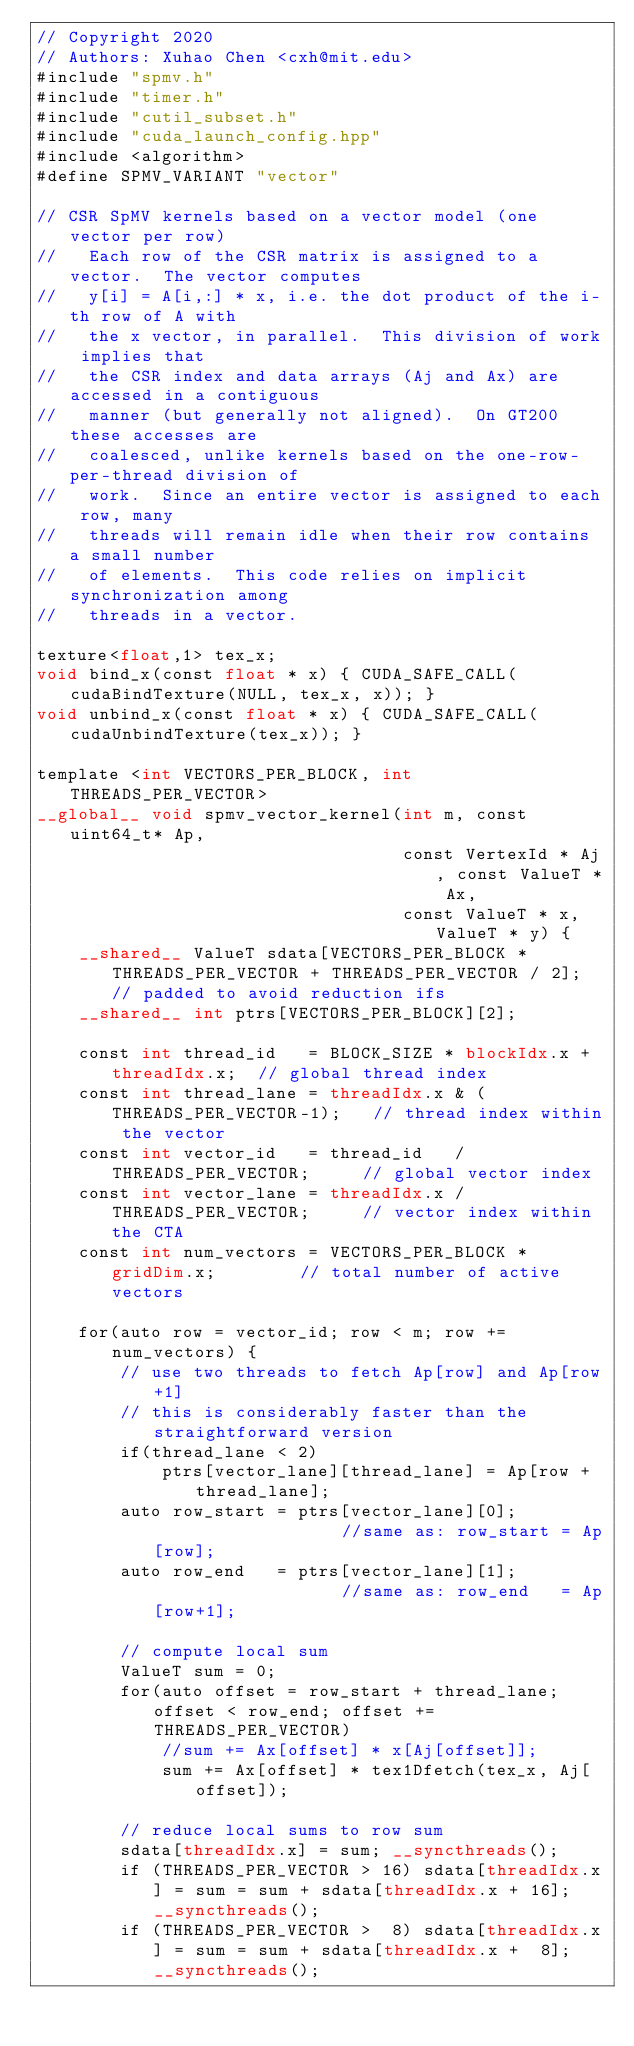Convert code to text. <code><loc_0><loc_0><loc_500><loc_500><_Cuda_>// Copyright 2020
// Authors: Xuhao Chen <cxh@mit.edu>
#include "spmv.h"
#include "timer.h"
#include "cutil_subset.h"
#include "cuda_launch_config.hpp"
#include <algorithm>
#define SPMV_VARIANT "vector"

// CSR SpMV kernels based on a vector model (one vector per row)
//   Each row of the CSR matrix is assigned to a vector.  The vector computes
//   y[i] = A[i,:] * x, i.e. the dot product of the i-th row of A with 
//   the x vector, in parallel.  This division of work implies that 
//   the CSR index and data arrays (Aj and Ax) are accessed in a contiguous
//   manner (but generally not aligned).  On GT200 these accesses are
//   coalesced, unlike kernels based on the one-row-per-thread division of 
//   work.  Since an entire vector is assigned to each row, many 
//   threads will remain idle when their row contains a small number 
//   of elements.  This code relies on implicit synchronization among 
//   threads in a vector.

texture<float,1> tex_x;
void bind_x(const float * x) { CUDA_SAFE_CALL(cudaBindTexture(NULL, tex_x, x)); }
void unbind_x(const float * x) { CUDA_SAFE_CALL(cudaUnbindTexture(tex_x)); }

template <int VECTORS_PER_BLOCK, int THREADS_PER_VECTOR>
__global__ void spmv_vector_kernel(int m, const uint64_t* Ap,
                                   const VertexId * Aj, const ValueT * Ax, 
                                   const ValueT * x, ValueT * y) {
	__shared__ ValueT sdata[VECTORS_PER_BLOCK * THREADS_PER_VECTOR + THREADS_PER_VECTOR / 2]; // padded to avoid reduction ifs
	__shared__ int ptrs[VECTORS_PER_BLOCK][2];

	const int thread_id	  = BLOCK_SIZE * blockIdx.x + threadIdx.x;  // global thread index
	const int thread_lane = threadIdx.x & (THREADS_PER_VECTOR-1);   // thread index within the vector
	const int vector_id   = thread_id   / THREADS_PER_VECTOR;     // global vector index
	const int vector_lane = threadIdx.x / THREADS_PER_VECTOR;     // vector index within the CTA
	const int num_vectors = VECTORS_PER_BLOCK * gridDim.x;        // total number of active vectors

	for(auto row = vector_id; row < m; row += num_vectors) {
		// use two threads to fetch Ap[row] and Ap[row+1]
		// this is considerably faster than the straightforward version
		if(thread_lane < 2)
			ptrs[vector_lane][thread_lane] = Ap[row + thread_lane];
		auto row_start = ptrs[vector_lane][0];                   //same as: row_start = Ap[row];
		auto row_end   = ptrs[vector_lane][1];                   //same as: row_end   = Ap[row+1];

		// compute local sum
		ValueT sum = 0;
		for(auto offset = row_start + thread_lane; offset < row_end; offset += THREADS_PER_VECTOR)
			//sum += Ax[offset] * x[Aj[offset]];
			sum += Ax[offset] * tex1Dfetch(tex_x, Aj[offset]);

		// reduce local sums to row sum
		sdata[threadIdx.x] = sum; __syncthreads();
		if (THREADS_PER_VECTOR > 16) sdata[threadIdx.x] = sum = sum + sdata[threadIdx.x + 16]; __syncthreads(); 
		if (THREADS_PER_VECTOR >  8) sdata[threadIdx.x] = sum = sum + sdata[threadIdx.x +  8]; __syncthreads();</code> 